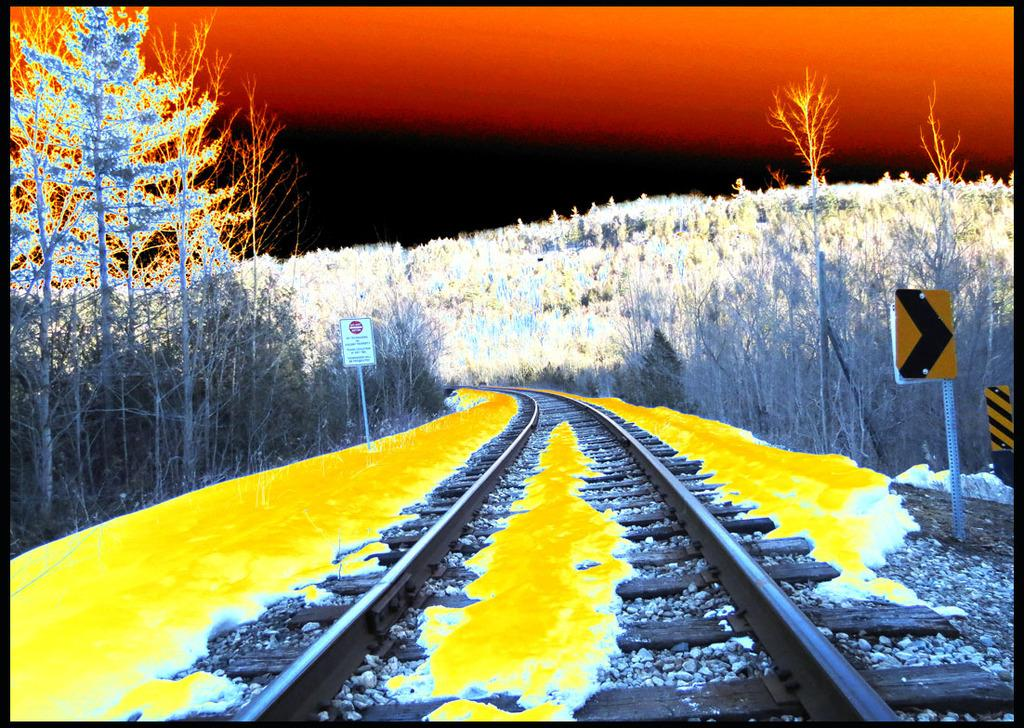What is the nature of the image? The image appears to be edited. What can be seen running through the image? There is a railway track in the image. What type of information might be conveyed by the sign boards in the image? The sign boards attached to poles in the image might convey information about directions, warnings, or other notices. What type of vegetation is visible in the image? Trees are visible in the image. What type of corn can be seen growing near the railway track in the image? There is no corn visible in the image; only trees are mentioned. What sound can be heard coming from the sign boards in the image? There is no sound associated with the sign boards in the image; they are static objects conveying information. 